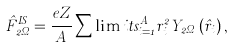Convert formula to latex. <formula><loc_0><loc_0><loc_500><loc_500>\hat { F } _ { 2 \Omega } ^ { I S } = \frac { e Z } { A } \sum \lim i t s _ { i = 1 } ^ { A } { r _ { i } ^ { 2 } Y _ { 2 \Omega } \left ( { \hat { r } _ { i } } \right ) , }</formula> 